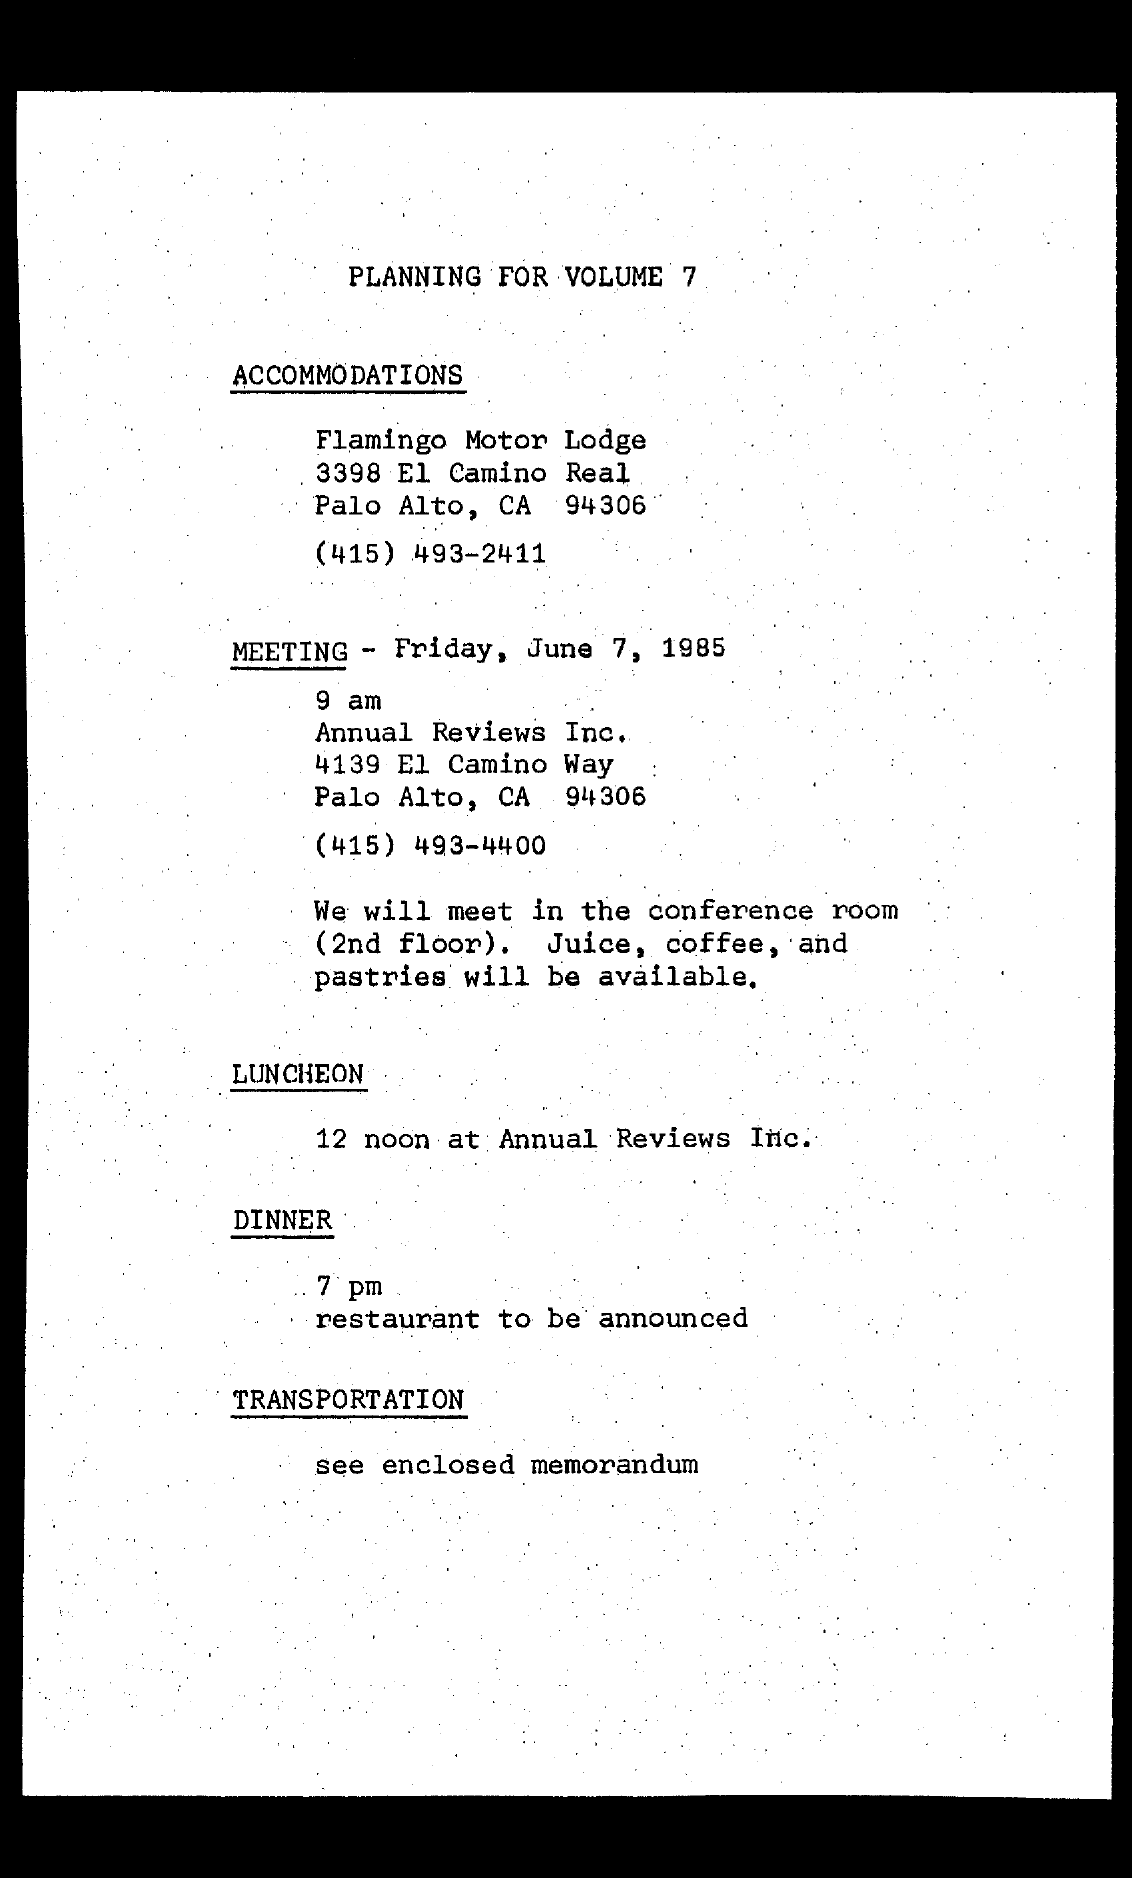Mention a couple of crucial points in this snapshot. Annual Reviews Inc.'s contact number is (415) 493-4400. The accommodation has been arranged according to the plan, and it is the Flamingo Motor Lodge. The meeting is scheduled to start at 9:00 AM on Friday, June 7, 1985. The dinner is scheduled to start at 7 pm according to the plan. According to the document, the meeting is scheduled for Friday, June 7, 1985. 